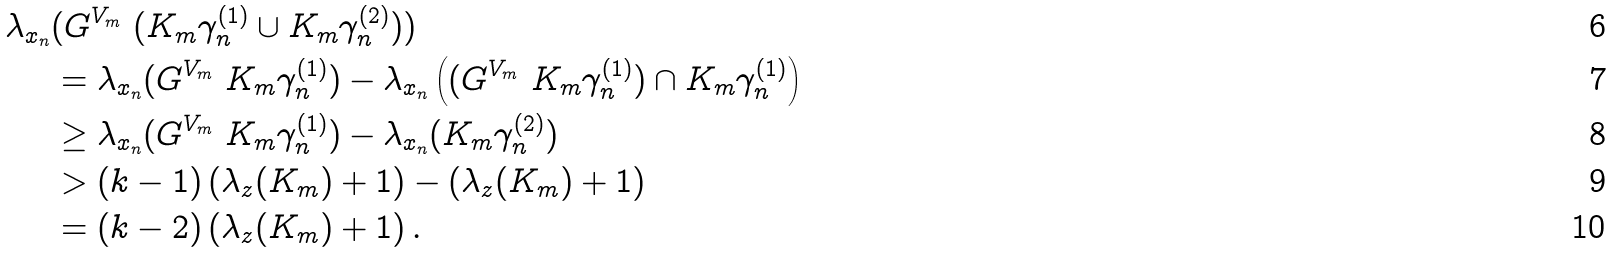Convert formula to latex. <formula><loc_0><loc_0><loc_500><loc_500>\lambda _ { x _ { n } } & ( G ^ { V _ { m } } \ ( K _ { m } \gamma _ { n } ^ { ( 1 ) } \cup K _ { m } \gamma _ { n } ^ { ( 2 ) } ) ) \\ & = \lambda _ { x _ { n } } ( G ^ { V _ { m } } \ K _ { m } \gamma _ { n } ^ { ( 1 ) } ) - \lambda _ { x _ { n } } \left ( ( G ^ { V _ { m } } \ K _ { m } \gamma _ { n } ^ { ( 1 ) } ) \cap K _ { m } \gamma _ { n } ^ { ( 1 ) } \right ) \\ & \geq \lambda _ { x _ { n } } ( G ^ { V _ { m } } \ K _ { m } \gamma _ { n } ^ { ( 1 ) } ) - \lambda _ { x _ { n } } ( K _ { m } \gamma _ { n } ^ { ( 2 ) } ) \\ & > ( k - 1 ) \left ( \lambda _ { z } ( K _ { m } ) + 1 \right ) - \left ( \lambda _ { z } ( K _ { m } ) + 1 \right ) \\ & = ( k - 2 ) \left ( \lambda _ { z } ( K _ { m } ) + 1 \right ) .</formula> 